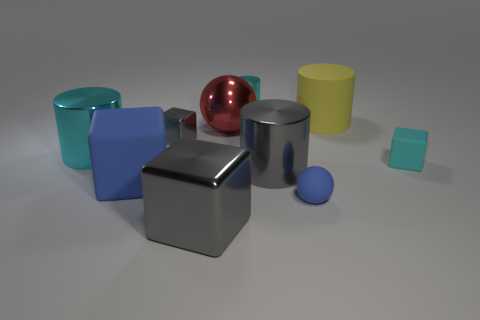Are the big yellow object and the sphere in front of the large cyan shiny object made of the same material?
Your answer should be very brief. Yes. How many large objects are brown shiny cylinders or yellow matte objects?
Your response must be concise. 1. There is a tiny thing that is the same color as the tiny shiny cylinder; what material is it?
Keep it short and to the point. Rubber. Are there fewer large cyan shiny cylinders than gray blocks?
Offer a very short reply. Yes. There is a blue rubber thing left of the gray cylinder; is its size the same as the shiny cylinder that is left of the blue rubber block?
Ensure brevity in your answer.  Yes. How many cyan things are large cylinders or matte balls?
Provide a succinct answer. 1. There is a rubber cube that is the same color as the small shiny cylinder; what is its size?
Provide a short and direct response. Small. Is the number of green shiny cylinders greater than the number of big things?
Ensure brevity in your answer.  No. Does the metallic sphere have the same color as the small rubber ball?
Offer a very short reply. No. What number of objects are either large green metallic objects or small blocks left of the tiny blue rubber ball?
Your response must be concise. 1. 